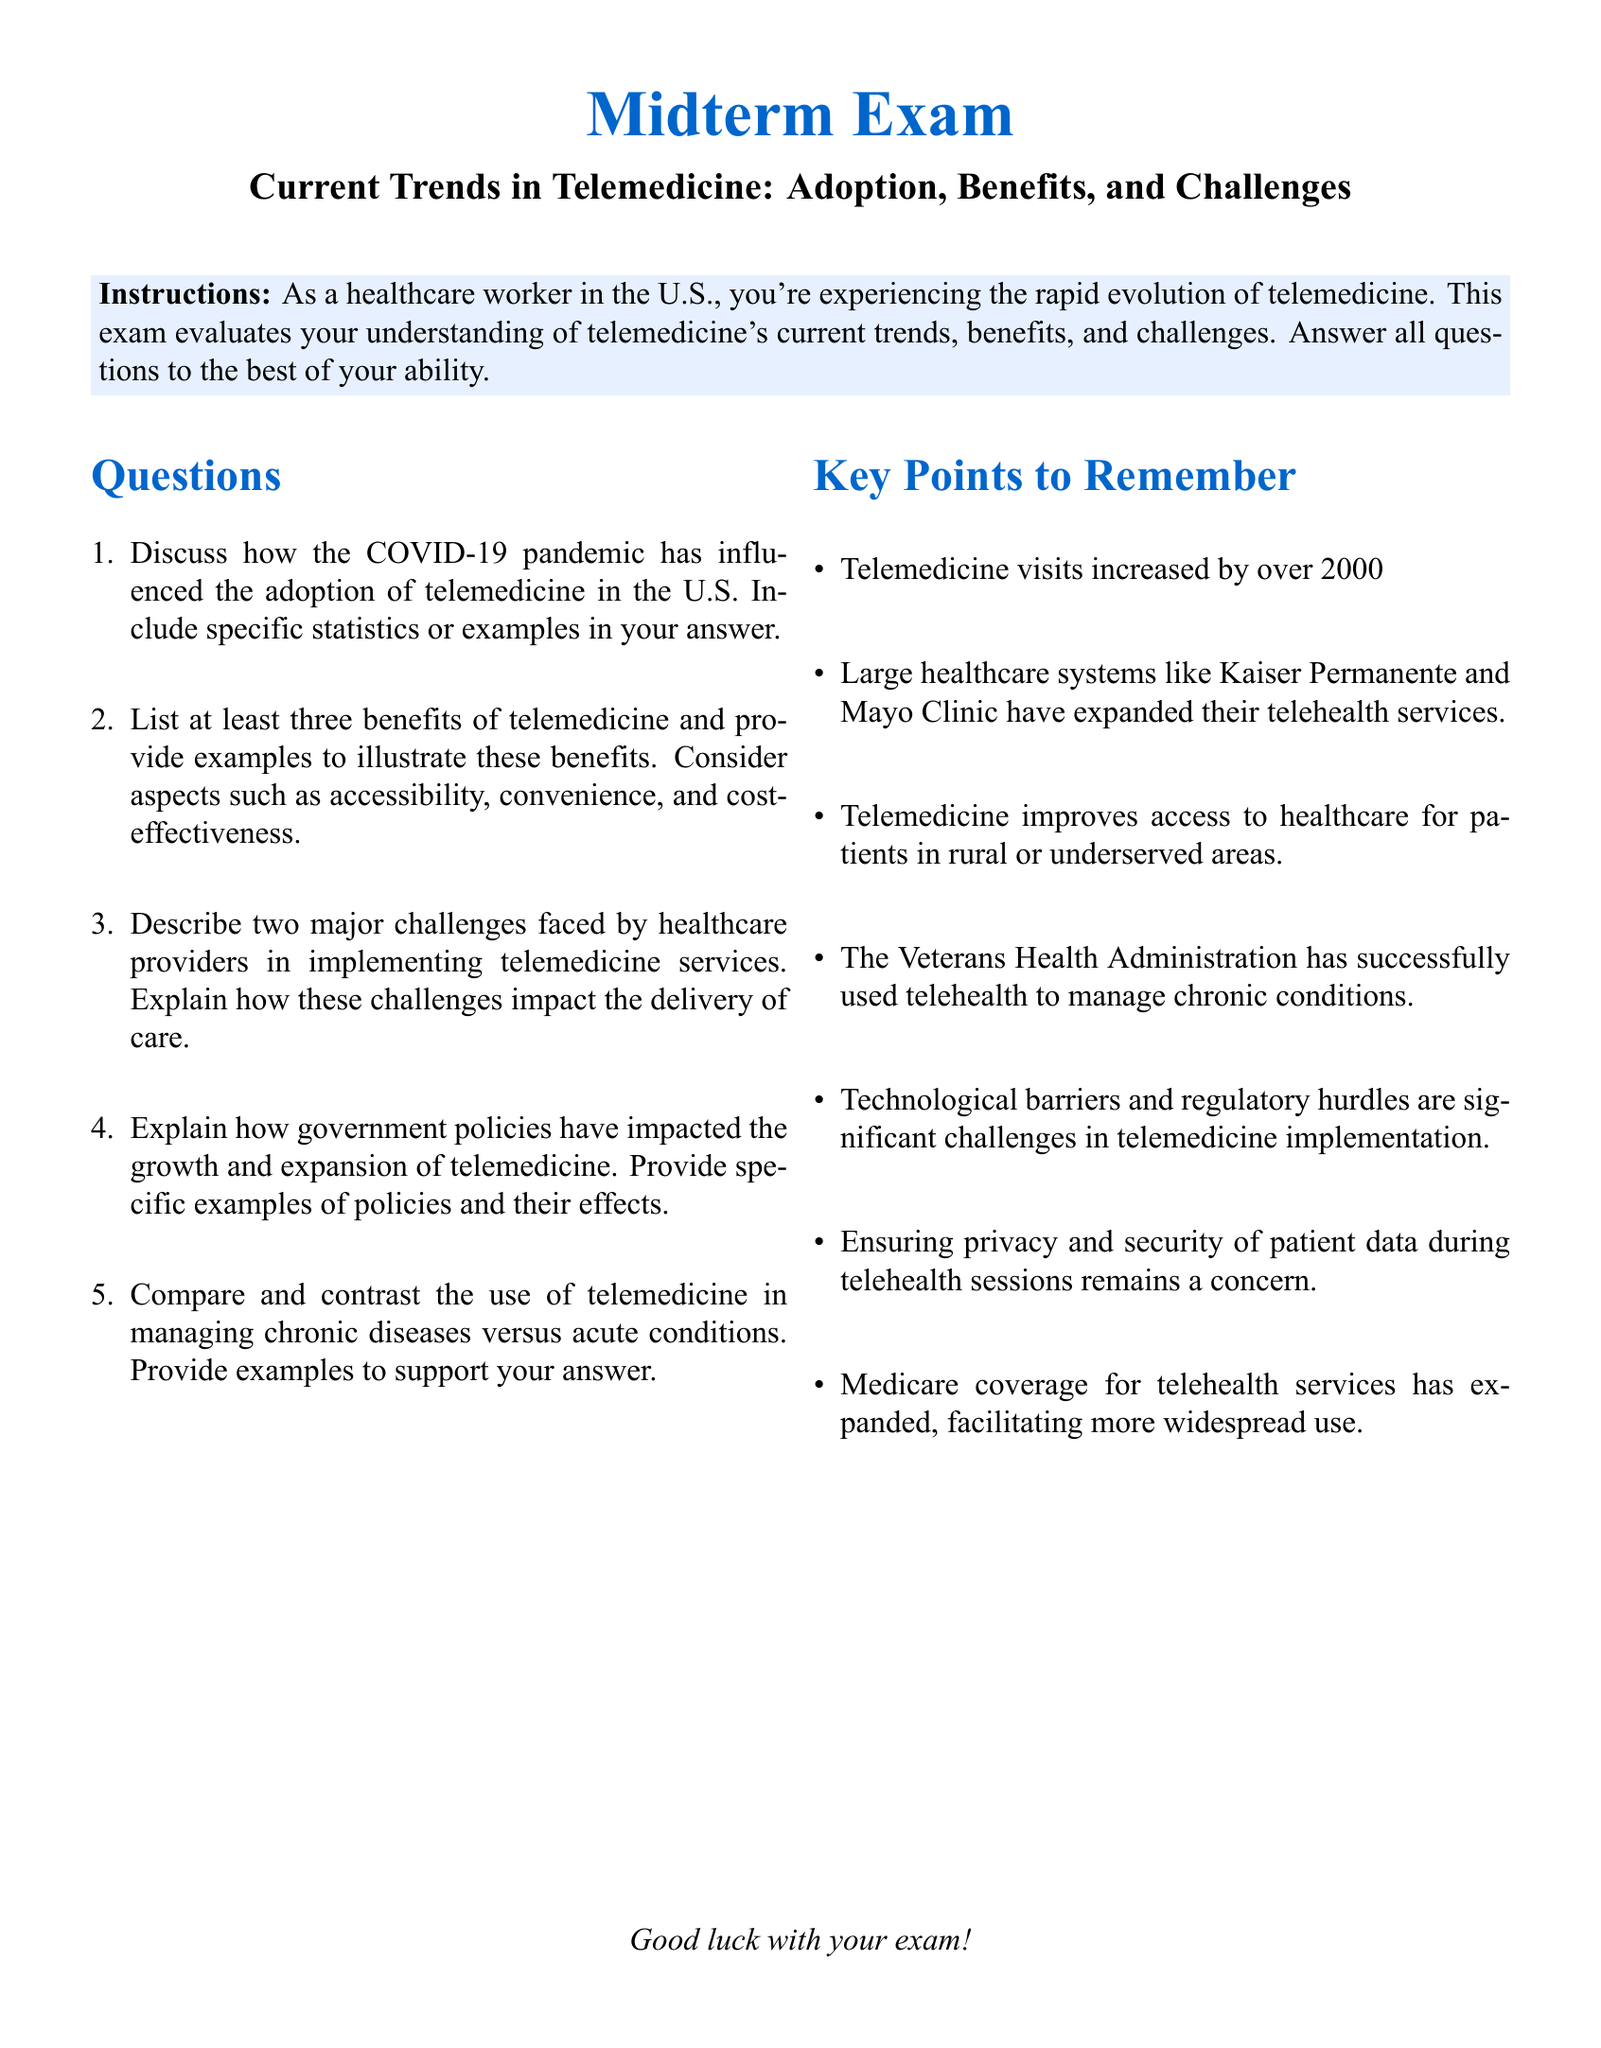What was the percentage increase in telemedicine visits between 2019 and 2020? The document states that telemedicine visits increased by over 2000% between 2019 and 2020.
Answer: 2000% Which two healthcare systems expanded their telehealth services? The document mentions that large healthcare systems like Kaiser Permanente and Mayo Clinic have expanded their telehealth services.
Answer: Kaiser Permanente and Mayo Clinic What is one major challenge faced by healthcare providers in implementing telemedicine? The document highlights technological barriers and regulatory hurdles as significant challenges in telemedicine implementation.
Answer: Technological barriers What is a benefit of telemedicine regarding patient access? The document states that telemedicine improves access to healthcare for patients in rural or underserved areas.
Answer: Access to healthcare Which organization successfully used telehealth to manage chronic conditions? The document mentions that the Veterans Health Administration has successfully used telehealth to manage chronic conditions.
Answer: Veterans Health Administration What policy has expanded Medicare coverage for telehealth services? The document indicates that Medicare coverage for telehealth services has expanded, facilitating more widespread use.
Answer: Medicare coverage expansion 